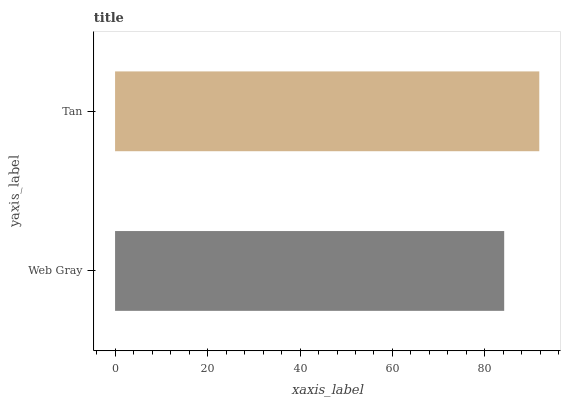Is Web Gray the minimum?
Answer yes or no. Yes. Is Tan the maximum?
Answer yes or no. Yes. Is Tan the minimum?
Answer yes or no. No. Is Tan greater than Web Gray?
Answer yes or no. Yes. Is Web Gray less than Tan?
Answer yes or no. Yes. Is Web Gray greater than Tan?
Answer yes or no. No. Is Tan less than Web Gray?
Answer yes or no. No. Is Tan the high median?
Answer yes or no. Yes. Is Web Gray the low median?
Answer yes or no. Yes. Is Web Gray the high median?
Answer yes or no. No. Is Tan the low median?
Answer yes or no. No. 